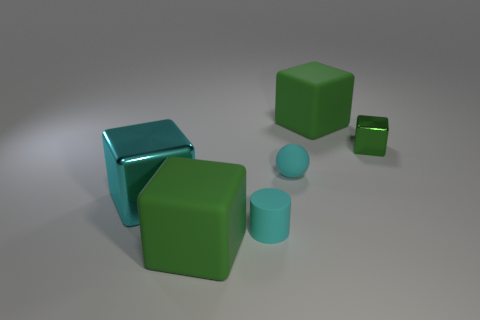Subtract all red spheres. How many green cubes are left? 3 Add 3 small yellow rubber balls. How many objects exist? 9 Subtract all cylinders. How many objects are left? 5 Subtract all big brown matte cubes. Subtract all small cyan rubber cylinders. How many objects are left? 5 Add 4 cyan blocks. How many cyan blocks are left? 5 Add 5 metallic objects. How many metallic objects exist? 7 Subtract 0 gray blocks. How many objects are left? 6 